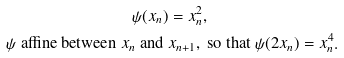<formula> <loc_0><loc_0><loc_500><loc_500>\psi ( x _ { n } ) & = x _ { n } ^ { 2 } , \\ \psi \text { affine\ between } x _ { n } \text { and } & x _ { n + 1 } , \text { so that } \psi ( 2 x _ { n } ) = x _ { n } ^ { 4 } .</formula> 